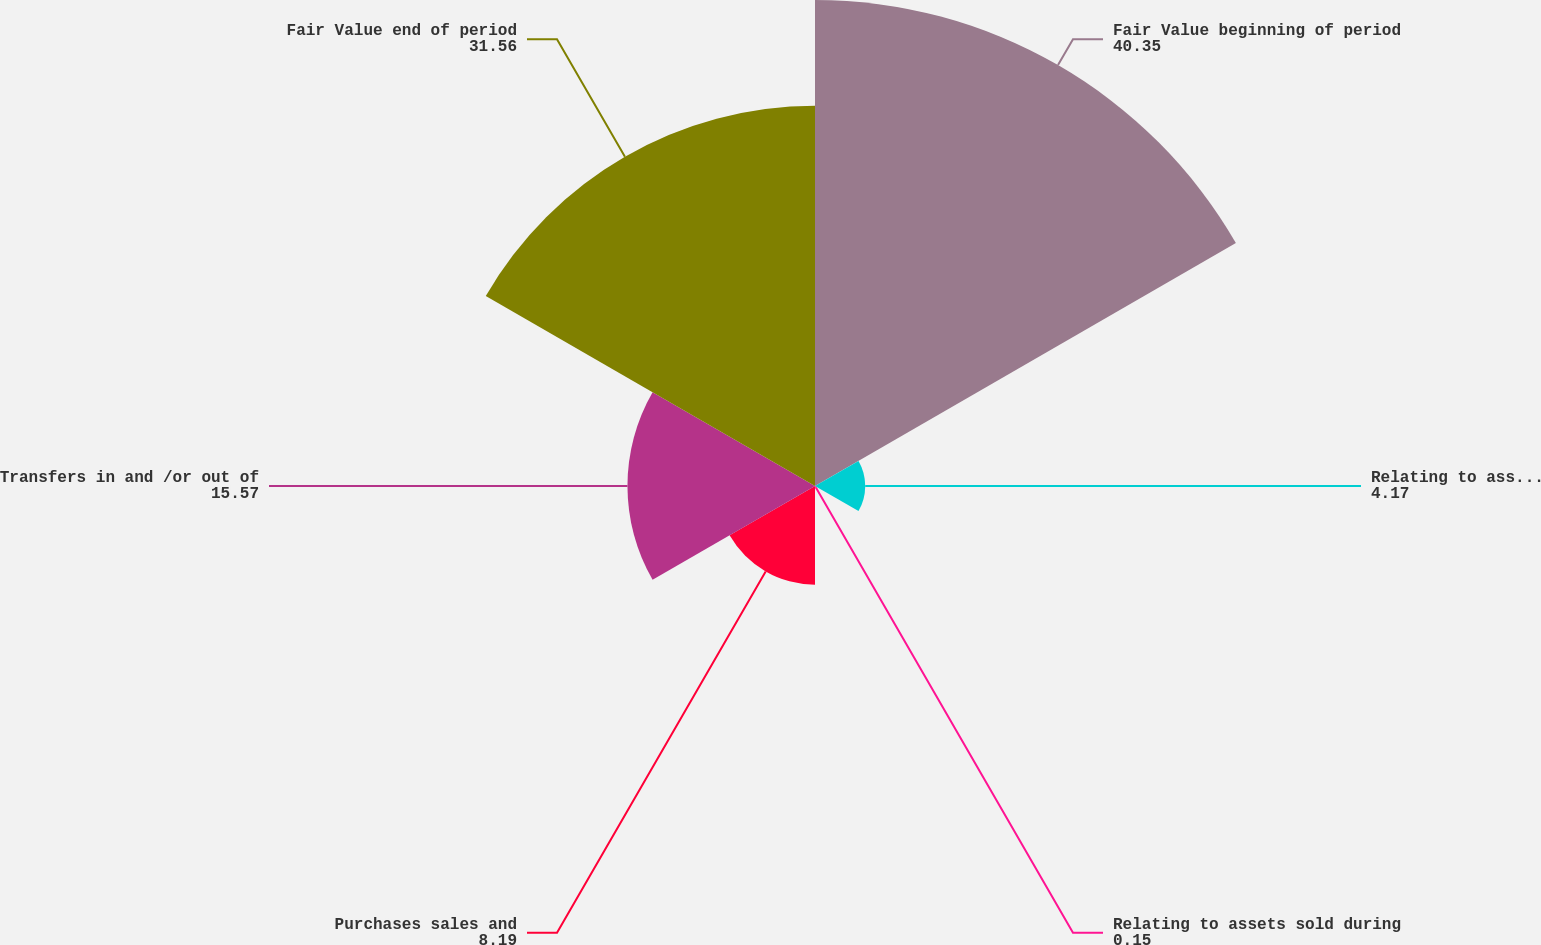<chart> <loc_0><loc_0><loc_500><loc_500><pie_chart><fcel>Fair Value beginning of period<fcel>Relating to assets still held<fcel>Relating to assets sold during<fcel>Purchases sales and<fcel>Transfers in and /or out of<fcel>Fair Value end of period<nl><fcel>40.35%<fcel>4.17%<fcel>0.15%<fcel>8.19%<fcel>15.57%<fcel>31.56%<nl></chart> 